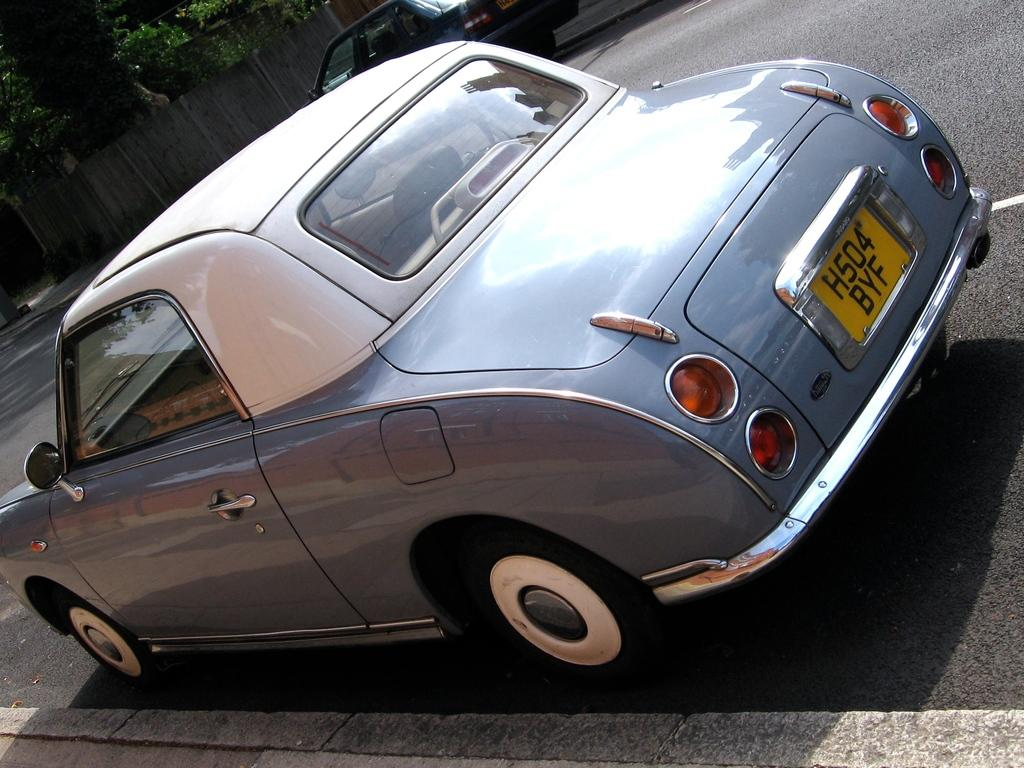What is the main subject of the image? The main subject of the image is a car on the road. Are there any other cars visible in the image? Yes, there is another black color car on the road in the image. What can be seen in the background of the image? There is a fence in the image. What type of vegetation is visible in the image? There is a tree on the right side top of the image. What type of business is being conducted in the image? There is no indication of any business being conducted in the image; it primarily features cars on the road and a tree in the background. 